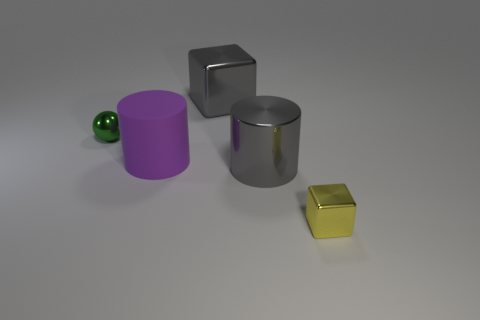What is the material of the block that is behind the tiny metal object to the left of the tiny metallic thing right of the purple matte thing?
Your response must be concise. Metal. How many other things are the same size as the gray shiny cylinder?
Your answer should be compact. 2. There is a large gray object that is the same shape as the small yellow metal object; what material is it?
Keep it short and to the point. Metal. The tiny block is what color?
Your response must be concise. Yellow. The metal block that is left of the small object that is right of the tiny green sphere is what color?
Your answer should be compact. Gray. Does the large metallic cylinder have the same color as the cube that is behind the big rubber cylinder?
Ensure brevity in your answer.  Yes. There is a tiny metallic object behind the large metallic object in front of the green thing; how many tiny green things are on the left side of it?
Your answer should be very brief. 0. There is a large rubber thing; are there any small yellow objects behind it?
Provide a succinct answer. No. Are there any other things of the same color as the ball?
Offer a very short reply. No. How many balls are either gray things or small shiny objects?
Ensure brevity in your answer.  1. 